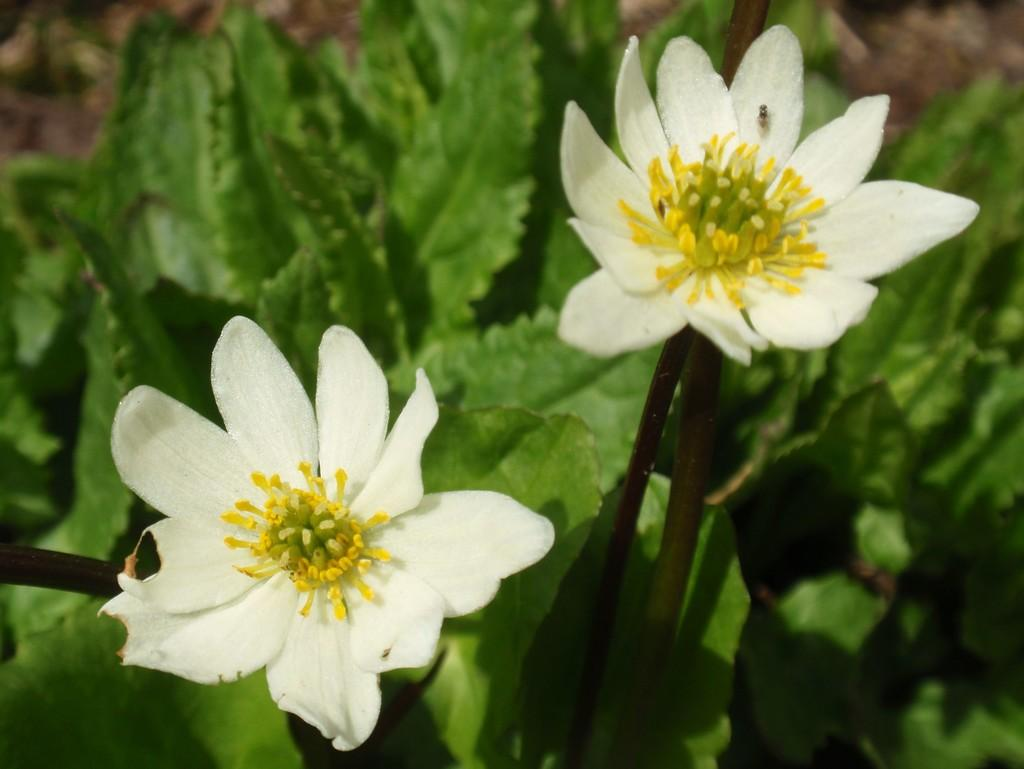What type of flowers can be seen in the image? There are white flowers in the image. What else is present in the image besides the flowers? There are leaves in the image. What type of plate is being used to burn the flowers in the image? There is no plate or burning activity present in the image; it features white flowers and leaves. 